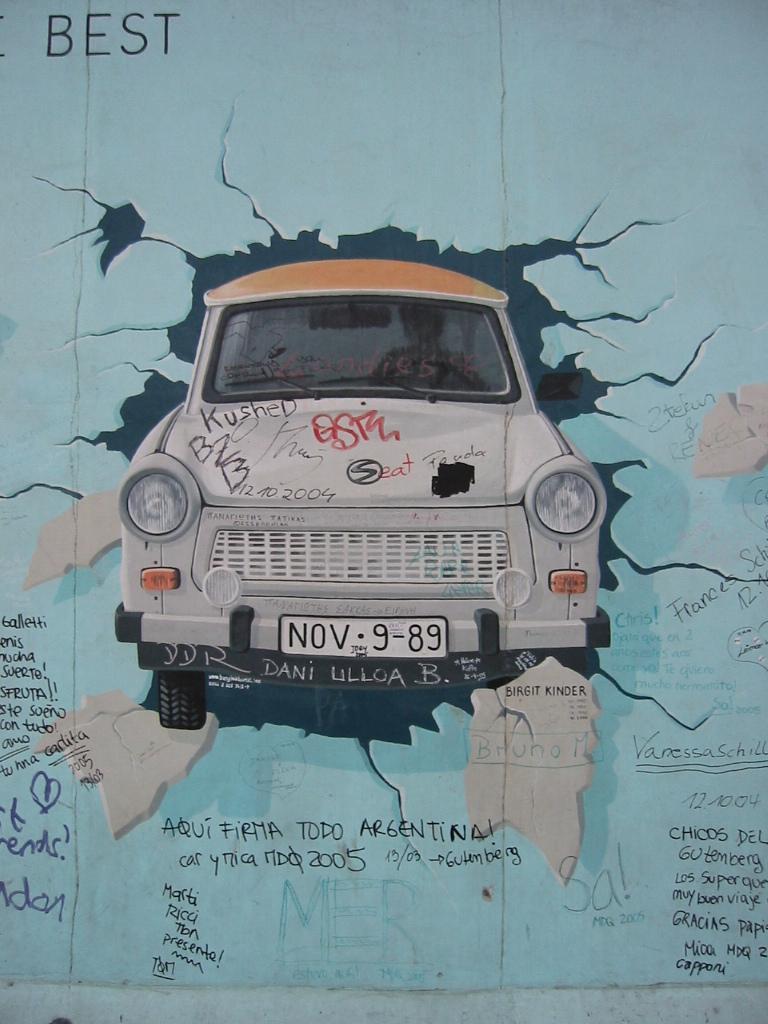Please provide a concise description of this image. In this image we can see a photo of a car with a set of lights and some text on it. 